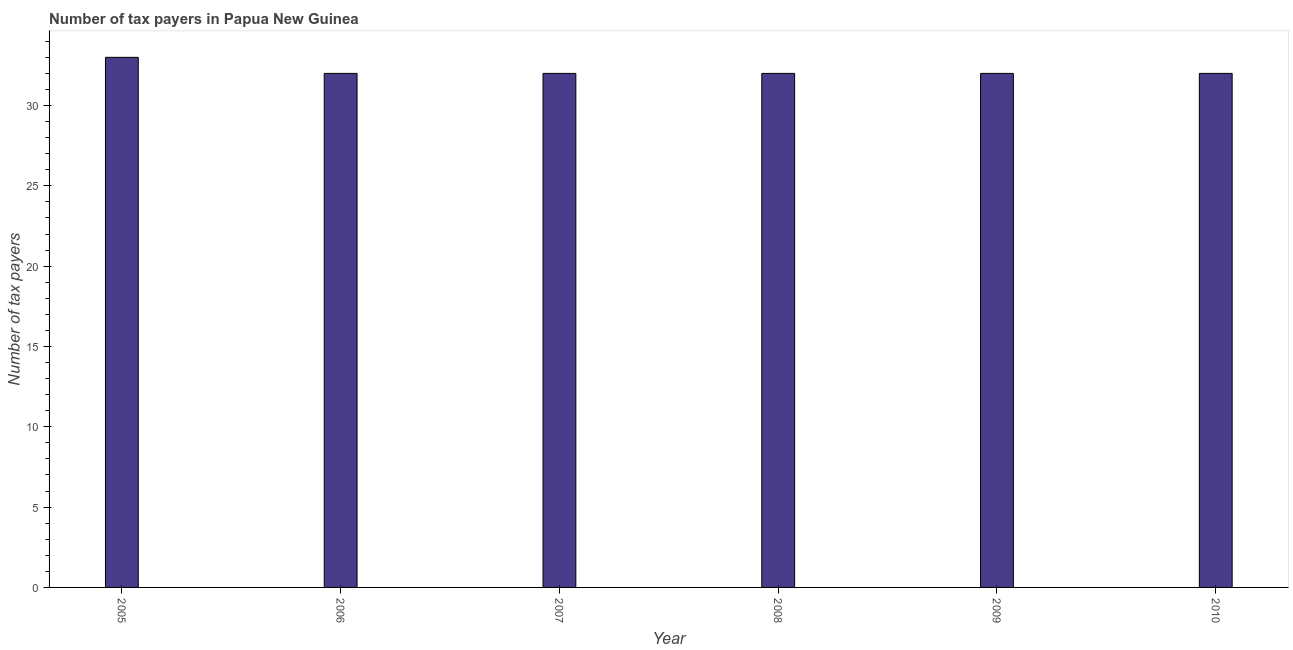Does the graph contain grids?
Keep it short and to the point. No. What is the title of the graph?
Your answer should be very brief. Number of tax payers in Papua New Guinea. What is the label or title of the X-axis?
Your answer should be very brief. Year. What is the label or title of the Y-axis?
Keep it short and to the point. Number of tax payers. What is the number of tax payers in 2008?
Ensure brevity in your answer.  32. Across all years, what is the maximum number of tax payers?
Offer a terse response. 33. In which year was the number of tax payers maximum?
Ensure brevity in your answer.  2005. In which year was the number of tax payers minimum?
Give a very brief answer. 2006. What is the sum of the number of tax payers?
Offer a terse response. 193. What is the median number of tax payers?
Ensure brevity in your answer.  32. What is the ratio of the number of tax payers in 2007 to that in 2009?
Your answer should be compact. 1. Is the difference between the number of tax payers in 2008 and 2010 greater than the difference between any two years?
Ensure brevity in your answer.  No. What is the difference between the highest and the lowest number of tax payers?
Offer a terse response. 1. In how many years, is the number of tax payers greater than the average number of tax payers taken over all years?
Keep it short and to the point. 1. How many years are there in the graph?
Provide a succinct answer. 6. What is the Number of tax payers of 2006?
Offer a terse response. 32. What is the Number of tax payers in 2007?
Provide a short and direct response. 32. What is the Number of tax payers of 2008?
Your answer should be compact. 32. What is the Number of tax payers in 2009?
Keep it short and to the point. 32. What is the Number of tax payers of 2010?
Give a very brief answer. 32. What is the difference between the Number of tax payers in 2005 and 2006?
Ensure brevity in your answer.  1. What is the difference between the Number of tax payers in 2005 and 2007?
Offer a terse response. 1. What is the difference between the Number of tax payers in 2005 and 2008?
Your answer should be very brief. 1. What is the difference between the Number of tax payers in 2007 and 2008?
Offer a very short reply. 0. What is the difference between the Number of tax payers in 2007 and 2010?
Give a very brief answer. 0. What is the difference between the Number of tax payers in 2009 and 2010?
Your response must be concise. 0. What is the ratio of the Number of tax payers in 2005 to that in 2006?
Your answer should be compact. 1.03. What is the ratio of the Number of tax payers in 2005 to that in 2007?
Offer a terse response. 1.03. What is the ratio of the Number of tax payers in 2005 to that in 2008?
Keep it short and to the point. 1.03. What is the ratio of the Number of tax payers in 2005 to that in 2009?
Your answer should be very brief. 1.03. What is the ratio of the Number of tax payers in 2005 to that in 2010?
Offer a very short reply. 1.03. What is the ratio of the Number of tax payers in 2006 to that in 2008?
Your response must be concise. 1. What is the ratio of the Number of tax payers in 2006 to that in 2009?
Your response must be concise. 1. What is the ratio of the Number of tax payers in 2007 to that in 2010?
Make the answer very short. 1. What is the ratio of the Number of tax payers in 2008 to that in 2009?
Provide a succinct answer. 1. What is the ratio of the Number of tax payers in 2008 to that in 2010?
Keep it short and to the point. 1. 